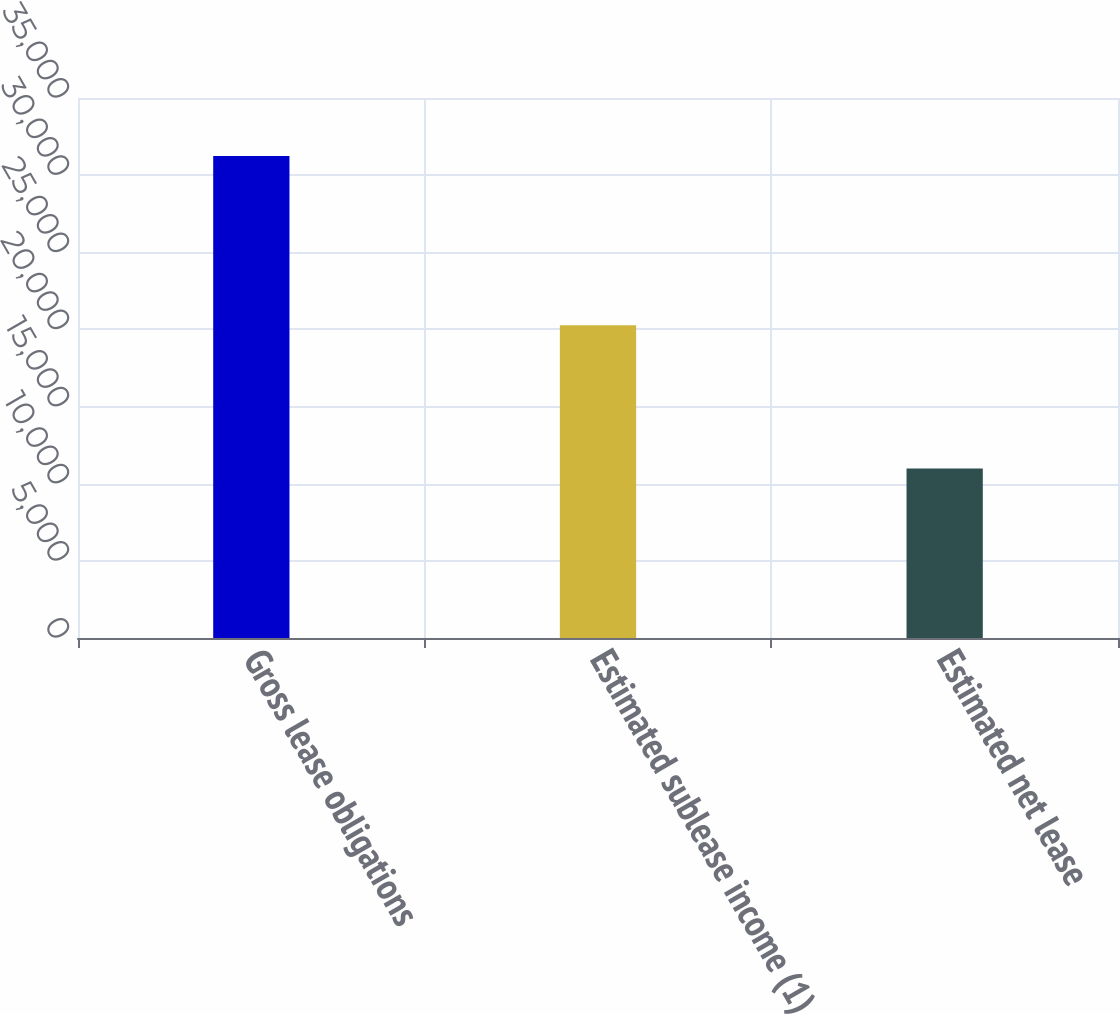Convert chart to OTSL. <chart><loc_0><loc_0><loc_500><loc_500><bar_chart><fcel>Gross lease obligations<fcel>Estimated sublease income (1)<fcel>Estimated net lease<nl><fcel>31243<fcel>20264<fcel>10979<nl></chart> 